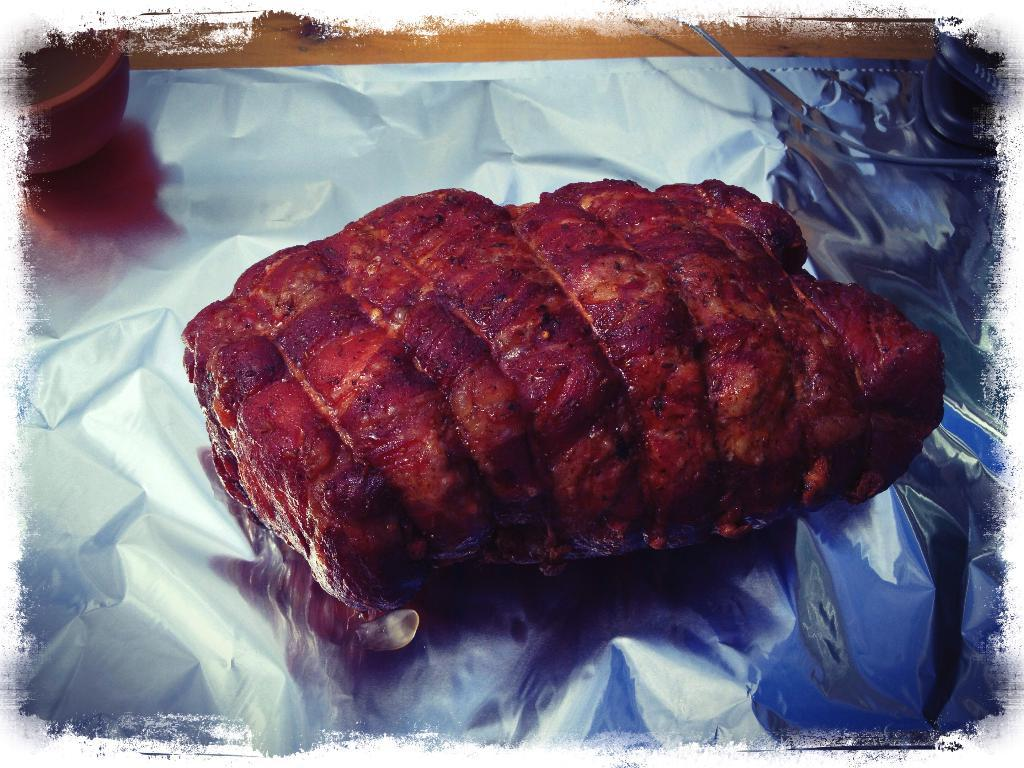What type of food is visible in the image? There is roasted meat in the image. How is the roasted meat being contained or wrapped? The roasted meat is on aluminium foil. What color is the shirt worn by the roasted meat in the image? There is no shirt worn by the roasted meat in the image, as it is an inanimate object and not a person or animal. 